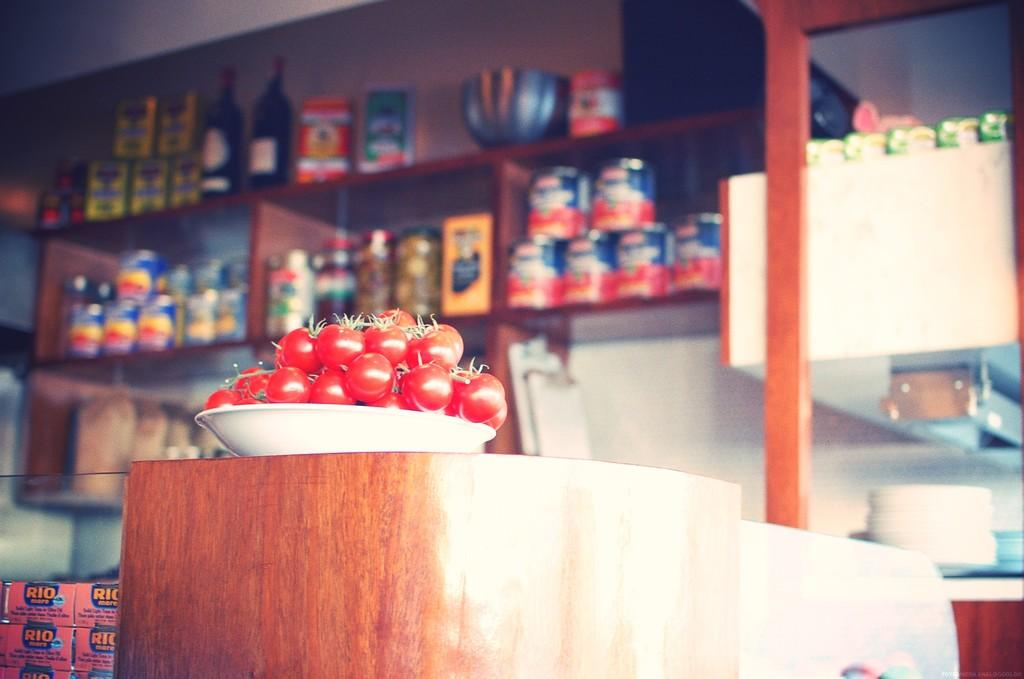What is in the bowl that is visible in the image? There are fruits in a bowl in the image. Where is the bowl located in the image? The bowl is placed on a platform. What can be seen in the background of the image? There are bottles, jars, shelves, and other unspecified objects in the background of the image. What type of art can be seen on the level surface in the image? There is no art or level surface present in the image. Is there a skateboard visible in the image? There is no skateboard present in the image. 